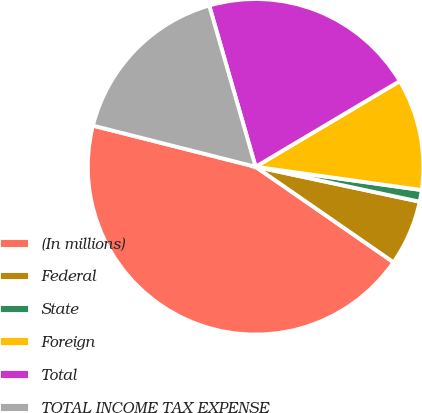Convert chart. <chart><loc_0><loc_0><loc_500><loc_500><pie_chart><fcel>(In millions)<fcel>Federal<fcel>State<fcel>Foreign<fcel>Total<fcel>TOTAL INCOME TAX EXPENSE<nl><fcel>44.31%<fcel>6.3%<fcel>1.12%<fcel>10.75%<fcel>20.92%<fcel>16.6%<nl></chart> 